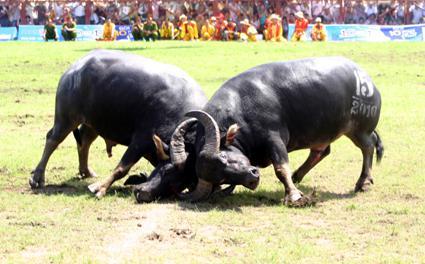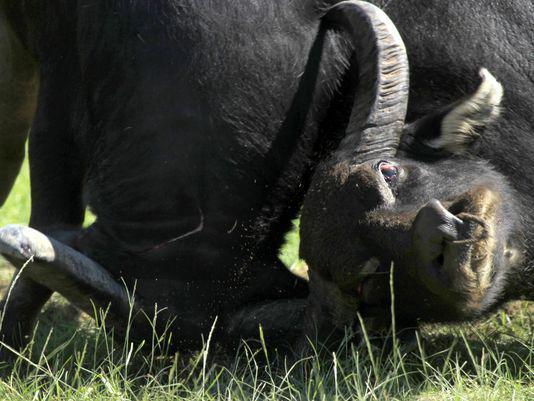The first image is the image on the left, the second image is the image on the right. Analyze the images presented: Is the assertion "At least one bison's head is touching the ground." valid? Answer yes or no. Yes. The first image is the image on the left, the second image is the image on the right. Analyze the images presented: Is the assertion "In the left image, both water buffalo have all four feet on the ground and their horns are locked." valid? Answer yes or no. Yes. 